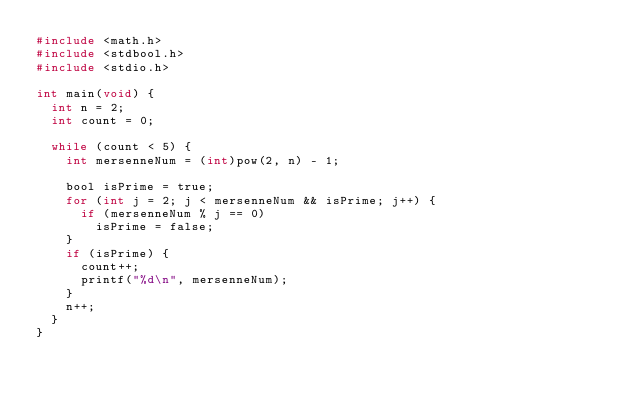<code> <loc_0><loc_0><loc_500><loc_500><_C_>#include <math.h>
#include <stdbool.h>
#include <stdio.h>

int main(void) {
  int n = 2;
  int count = 0;

  while (count < 5) {
    int mersenneNum = (int)pow(2, n) - 1;

    bool isPrime = true;
    for (int j = 2; j < mersenneNum && isPrime; j++) {
      if (mersenneNum % j == 0)
        isPrime = false;
    }
    if (isPrime) {
      count++;
      printf("%d\n", mersenneNum);
    }
    n++;
  }
}</code> 